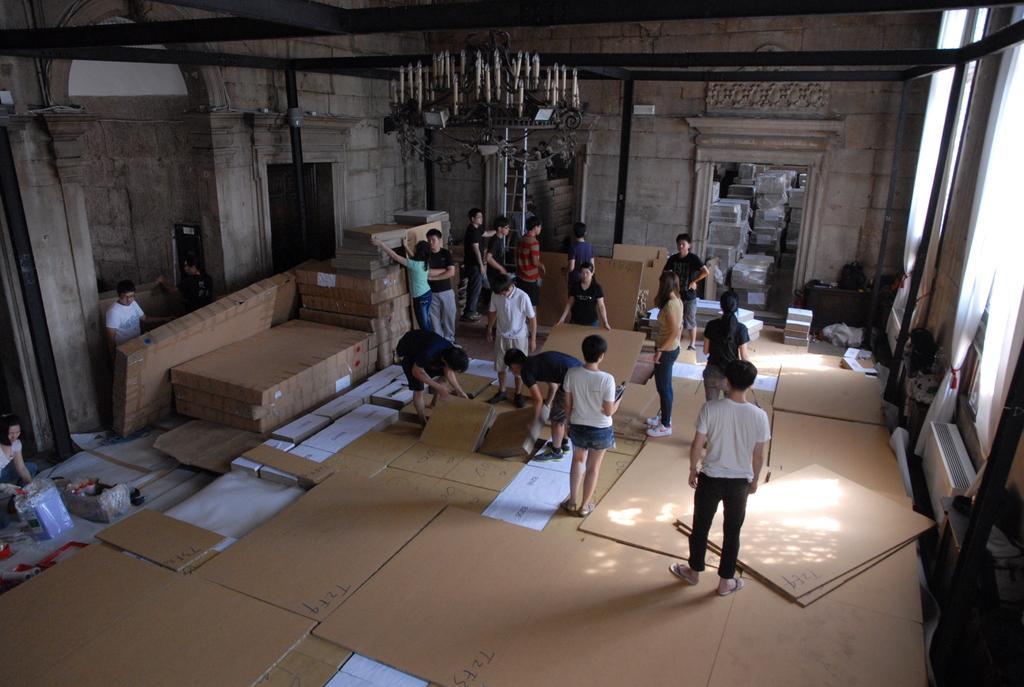Please provide a concise description of this image. In this image, we can see a group of people, boxes, walls, ladder, poles and few objects. Top of the image, we can see the chandelier. On the right side of the image, we can see curtains. On the left side , we can see a woman and few objects. 